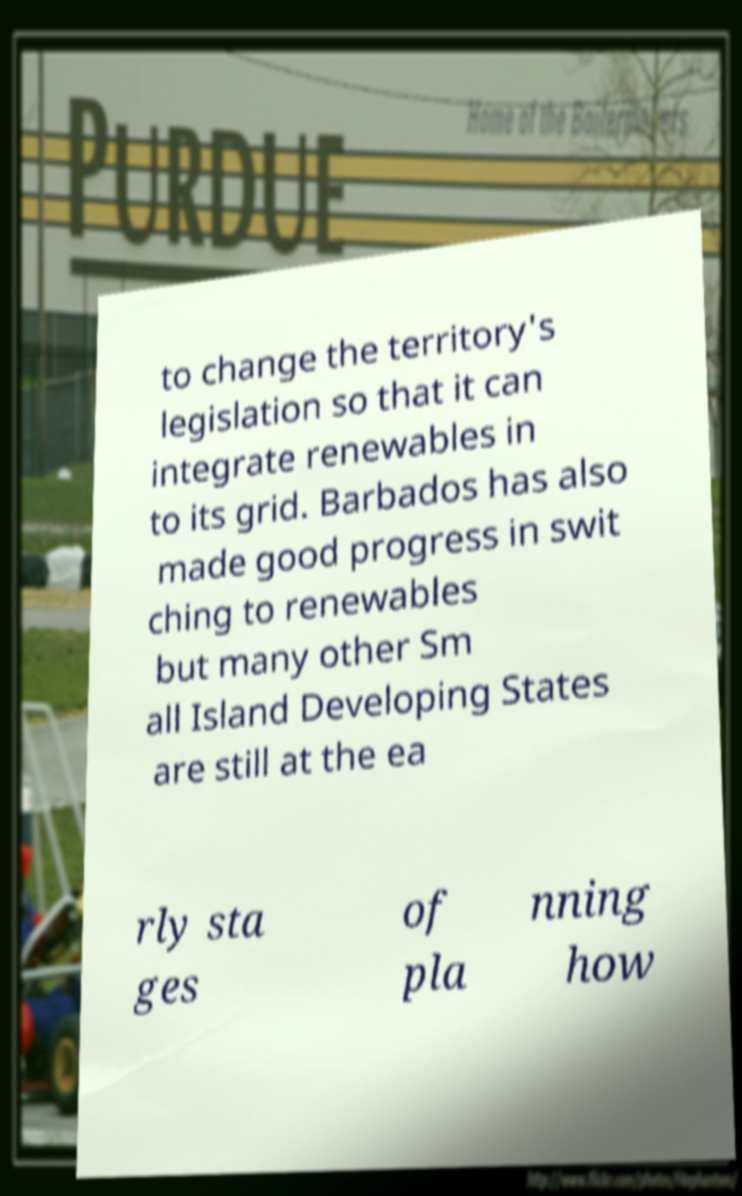Could you assist in decoding the text presented in this image and type it out clearly? to change the territory's legislation so that it can integrate renewables in to its grid. Barbados has also made good progress in swit ching to renewables but many other Sm all Island Developing States are still at the ea rly sta ges of pla nning how 